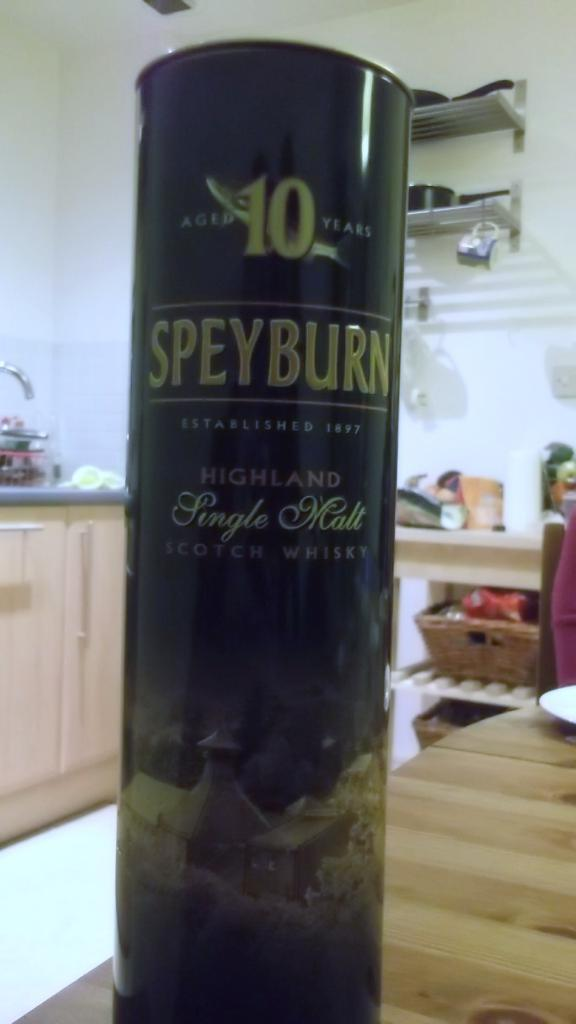<image>
Present a compact description of the photo's key features. the name speyburn is on a thin can 